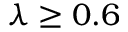<formula> <loc_0><loc_0><loc_500><loc_500>\lambda \geq 0 . 6</formula> 